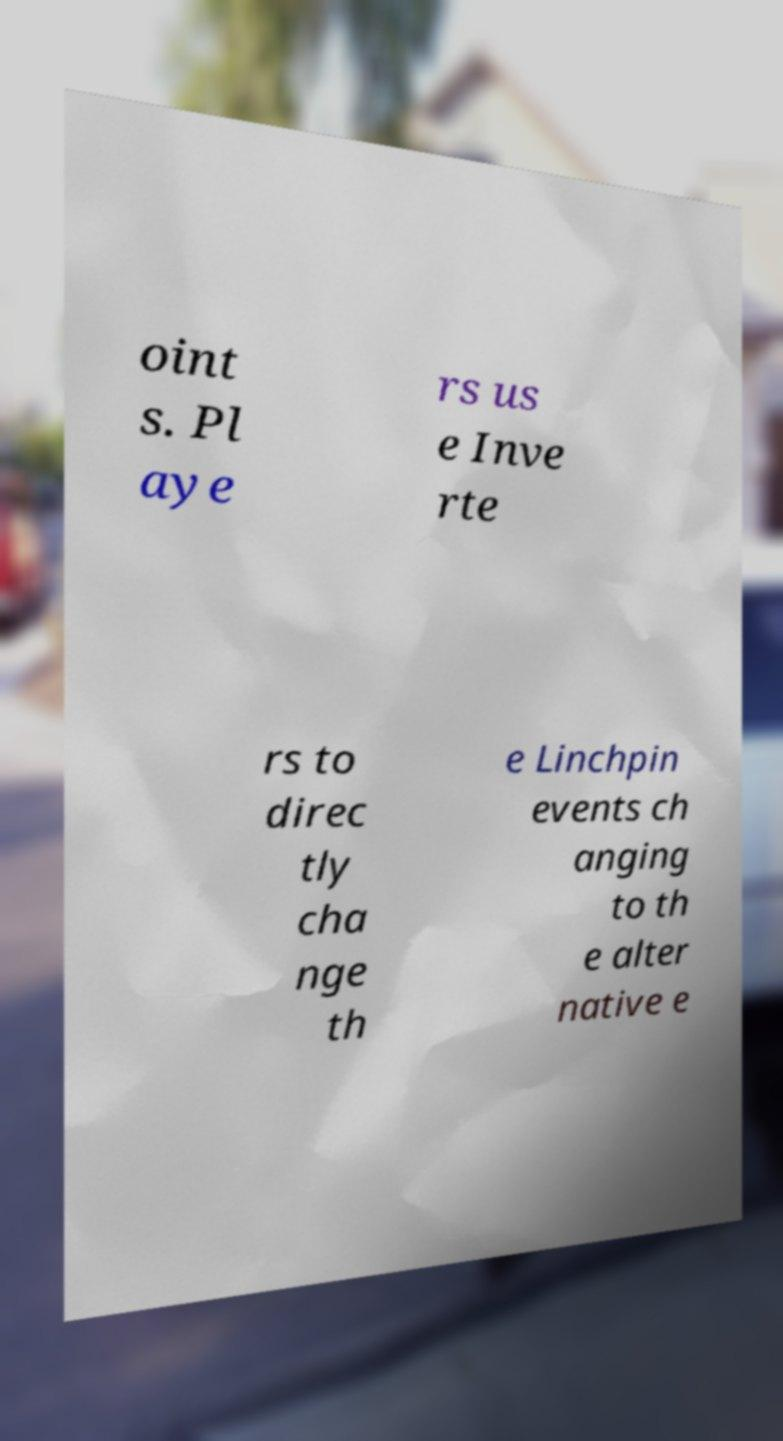What messages or text are displayed in this image? I need them in a readable, typed format. oint s. Pl aye rs us e Inve rte rs to direc tly cha nge th e Linchpin events ch anging to th e alter native e 